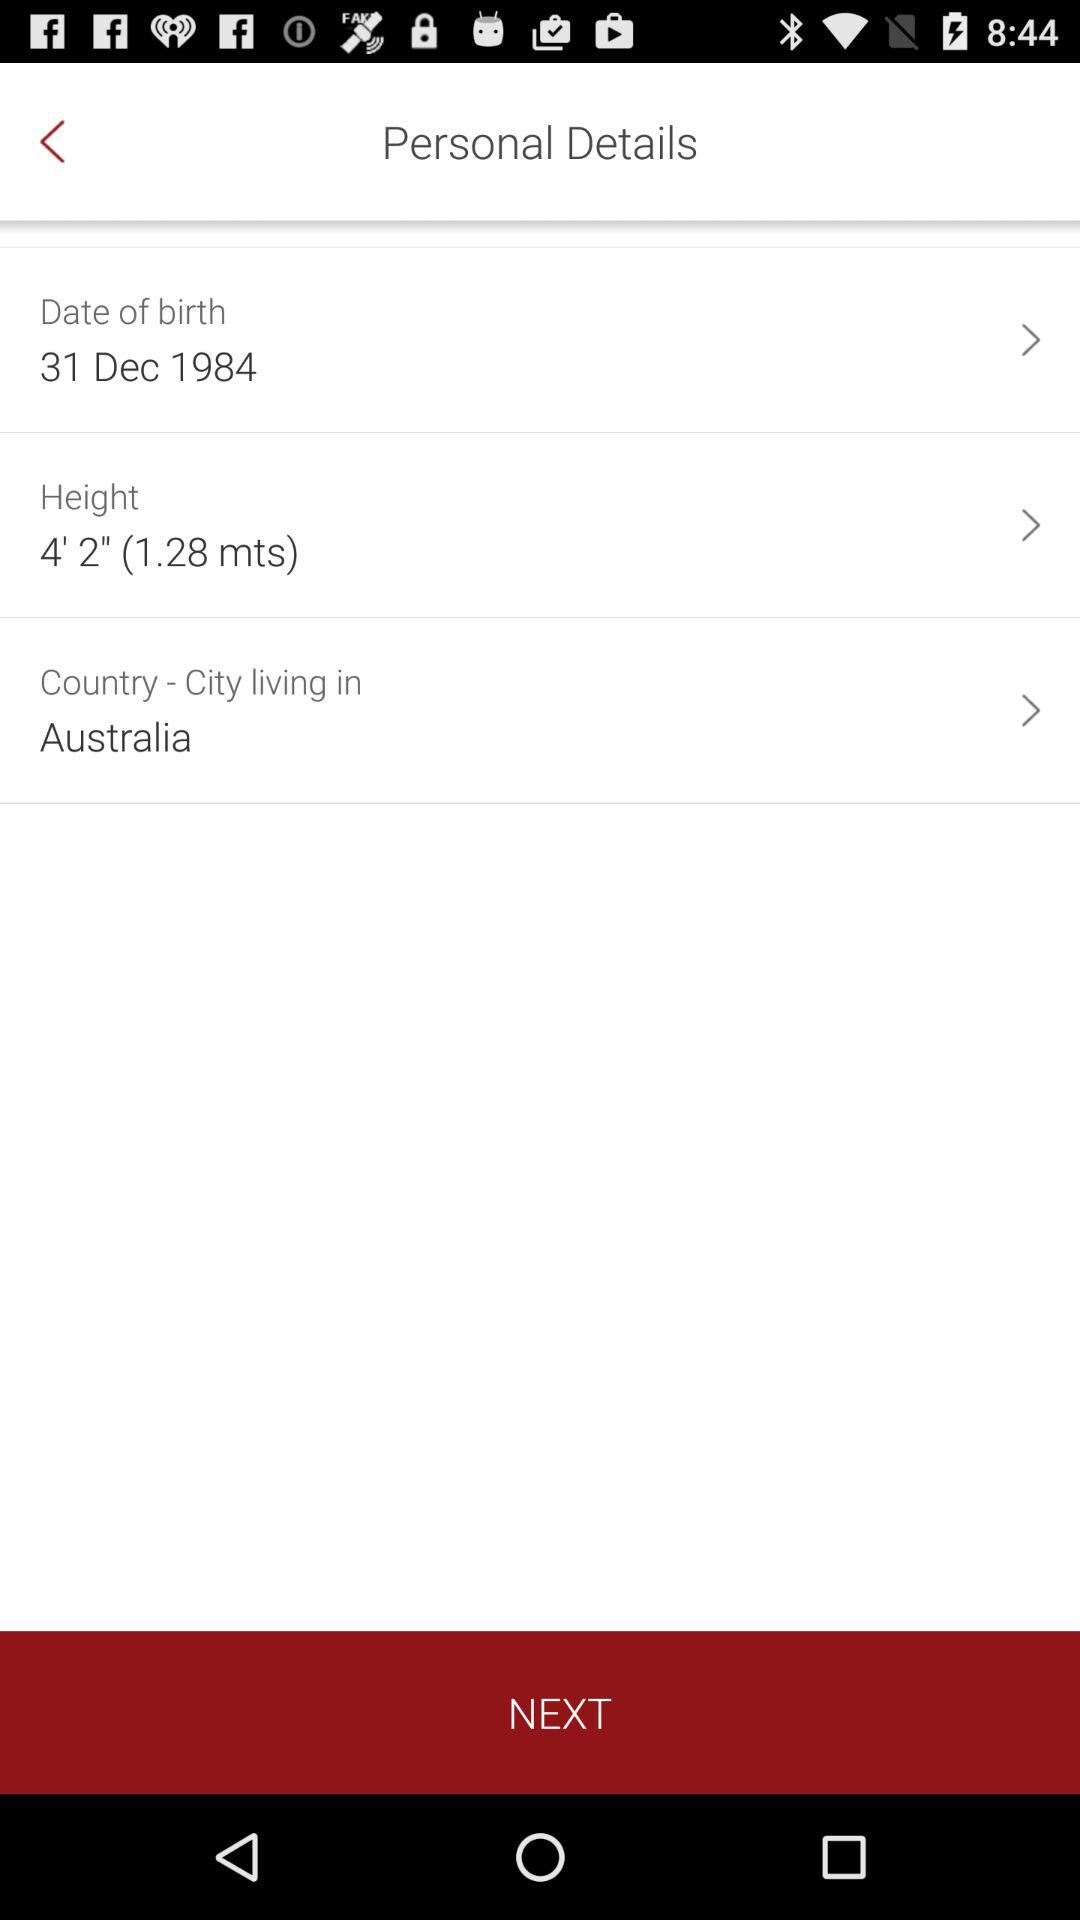What is the height? The height is 4' 2" (1.28 mts). 